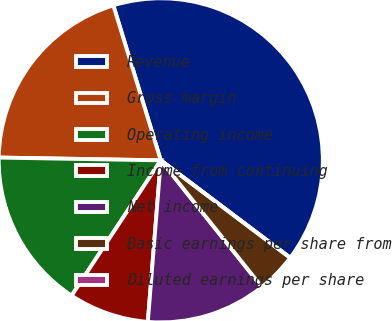Convert chart. <chart><loc_0><loc_0><loc_500><loc_500><pie_chart><fcel>Revenue<fcel>Gross margin<fcel>Operating income<fcel>Income from continuing<fcel>Net income<fcel>Basic earnings per share from<fcel>Diluted earnings per share<nl><fcel>40.0%<fcel>20.0%<fcel>16.0%<fcel>8.0%<fcel>12.0%<fcel>4.0%<fcel>0.0%<nl></chart> 